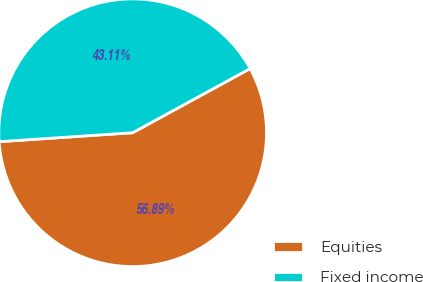<chart> <loc_0><loc_0><loc_500><loc_500><pie_chart><fcel>Equities<fcel>Fixed income<nl><fcel>56.89%<fcel>43.11%<nl></chart> 